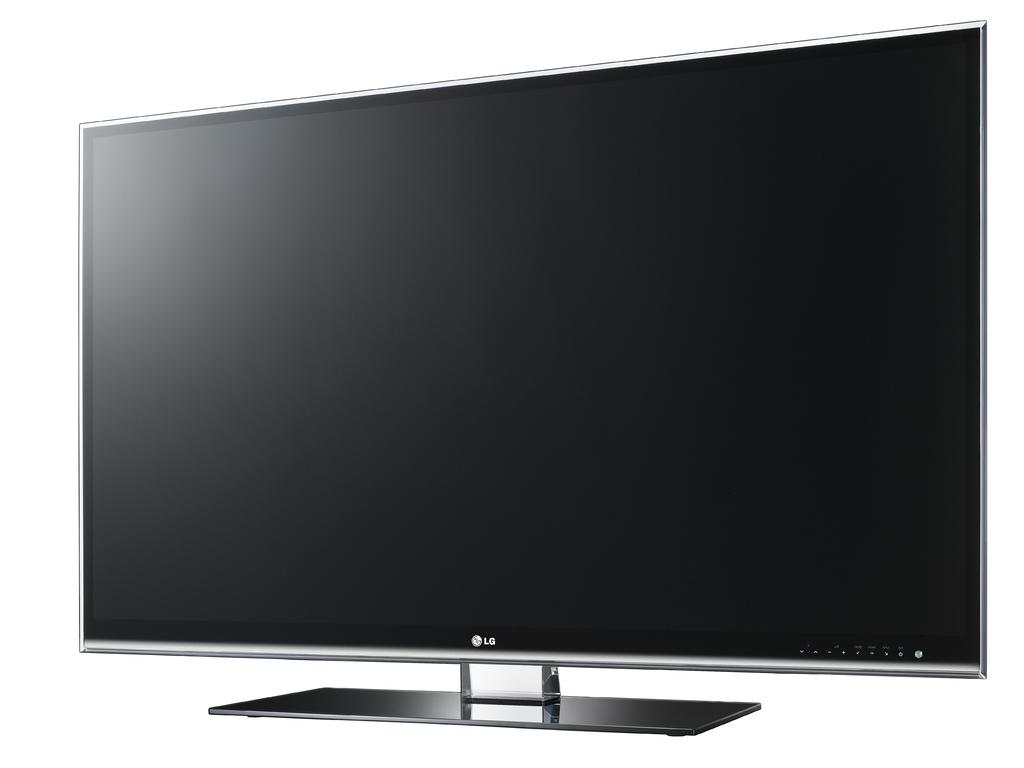<image>
Present a compact description of the photo's key features. an LG tv that is not turned on at the moment 